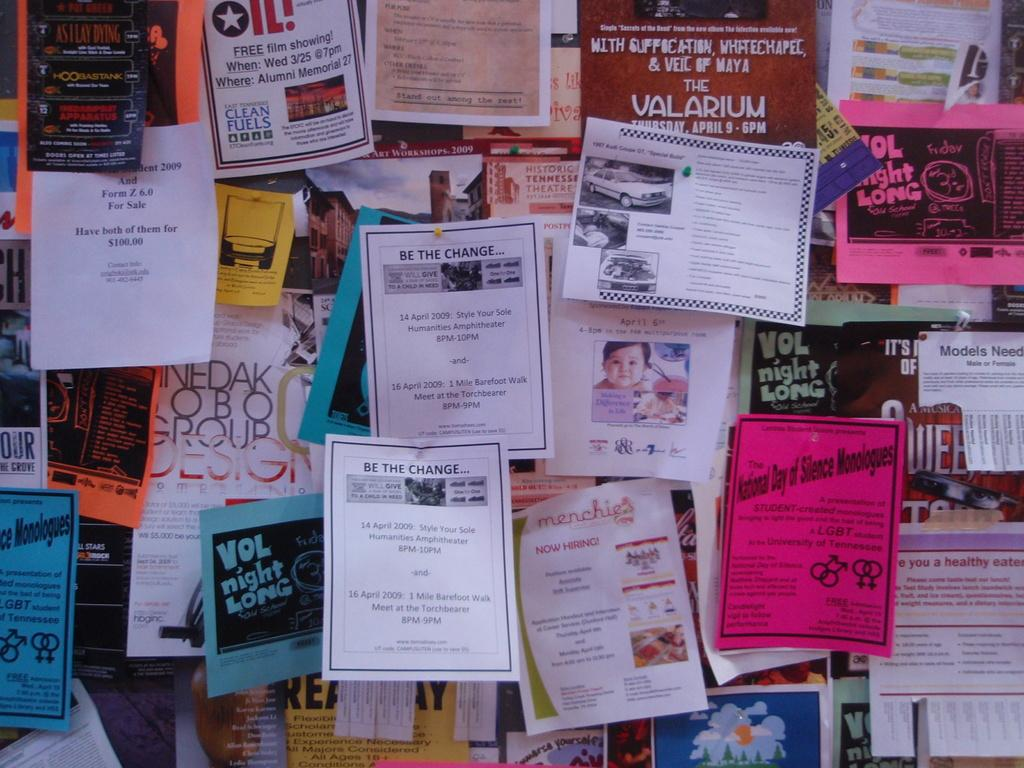<image>
Create a compact narrative representing the image presented. a board of posters with one of them that says 'be the change' 